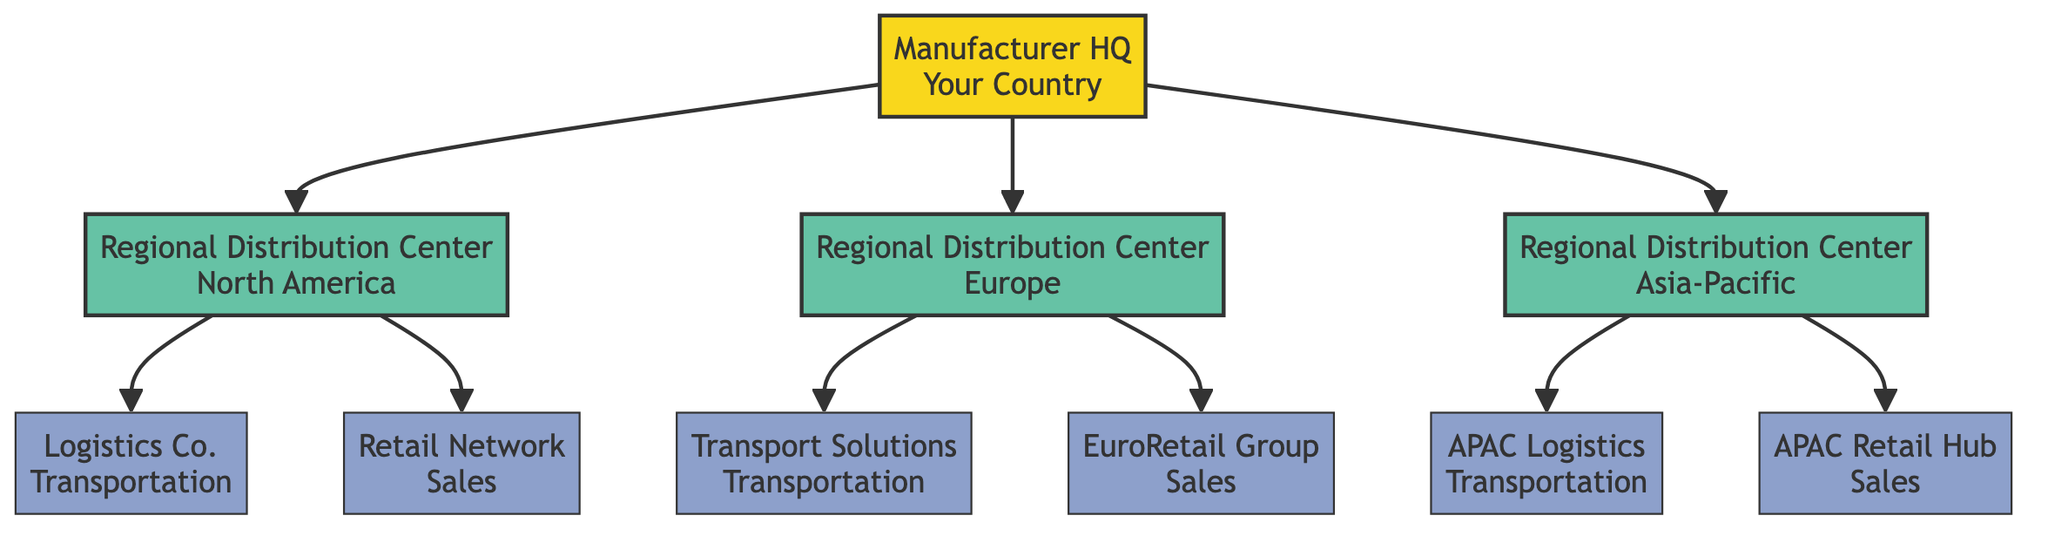What is the name of the root node? The root node is the topmost node in the diagram. It is labeled "Manufacturer HQ."
Answer: Manufacturer HQ How many Regional Distribution Centers are there? To find the number of Regional Distribution Centers, we can count the nodes labeled "Regional Distribution Center." There are three such nodes in the diagram, each representing a different region.
Answer: 3 What services does Logistics Co. provide? By examining the node connected to "Logistics Co.," we see the services listed are "Freight" and "Warehousing."
Answer: Freight, Warehousing Which Regional Distribution Center partners with EuroRetail Group? The connection leading to "EuroRetail Group" can be traced upwards to see which Regional Distribution Center it is associated with. It is linked to the one located in "Europe."
Answer: Europe What type of partner is APAC Retail Hub? The node "APAC Retail Hub" is labeled with the type "Sales" which categorizes it as a sales partner in the distribution network.
Answer: Sales Which location does APAC Logistics cover? By following the connections, we see that "APAC Logistics" is associated with the Regional Distribution Center in "Asia-Pacific."
Answer: Asia-Pacific What are the two services provided by Transport Solutions? Looking at the node for "Transport Solutions," we find the services listed as "Freight" and "Last Mile Delivery."
Answer: Freight, Last Mile Delivery Which type of partner is Retail Network? The node labeled "Retail Network" indicates its category as "Sales," providing clarity on the type of partner it represents within the network.
Answer: Sales Which Regional Distribution Center is connected to APAC Logistics? Tracing the connection from "APAC Logistics," we can see it connects to the Regional Distribution Center located in "Asia-Pacific."
Answer: Asia-Pacific 